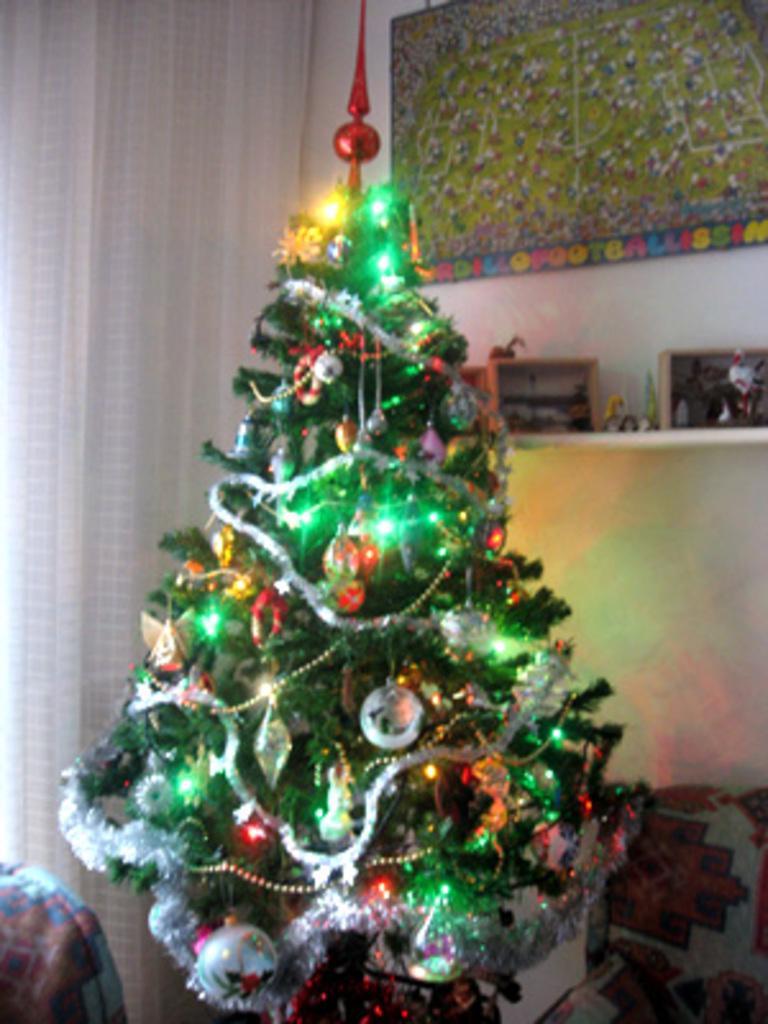Please provide a concise description of this image. In this image there is a Christmas tree. There are many decorative things on the Christmas tree. To the left there is a curtain to the wall. Behind the tree there is a rack to the wall. There are few objects on the rack. There is a frame on the wall. 